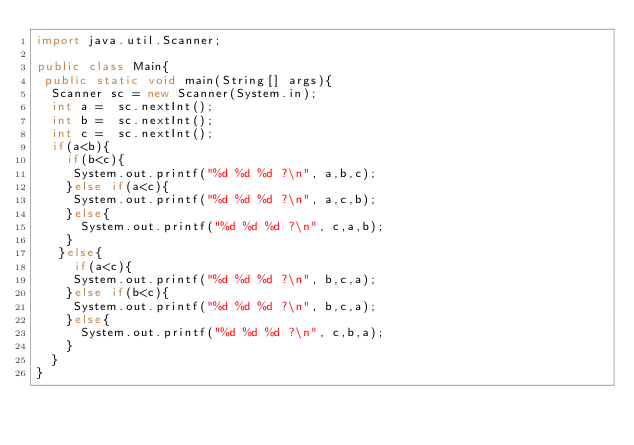Convert code to text. <code><loc_0><loc_0><loc_500><loc_500><_Java_>import java.util.Scanner;

public class Main{
 public static void main(String[] args){
  Scanner sc = new Scanner(System.in);
  int a =  sc.nextInt();
  int b =  sc.nextInt();
  int c =  sc.nextInt();
  if(a<b){
    if(b<c){
     System.out.printf("%d %d %d ?\n", a,b,c);
    }else if(a<c){
     System.out.printf("%d %d %d ?\n", a,c,b);
    }else{
      System.out.printf("%d %d %d ?\n", c,a,b);
    }
   }else{
     if(a<c){
     System.out.printf("%d %d %d ?\n", b,c,a);
    }else if(b<c){
     System.out.printf("%d %d %d ?\n", b,c,a);
    }else{
      System.out.printf("%d %d %d ?\n", c,b,a);
    }
  }
}</code> 